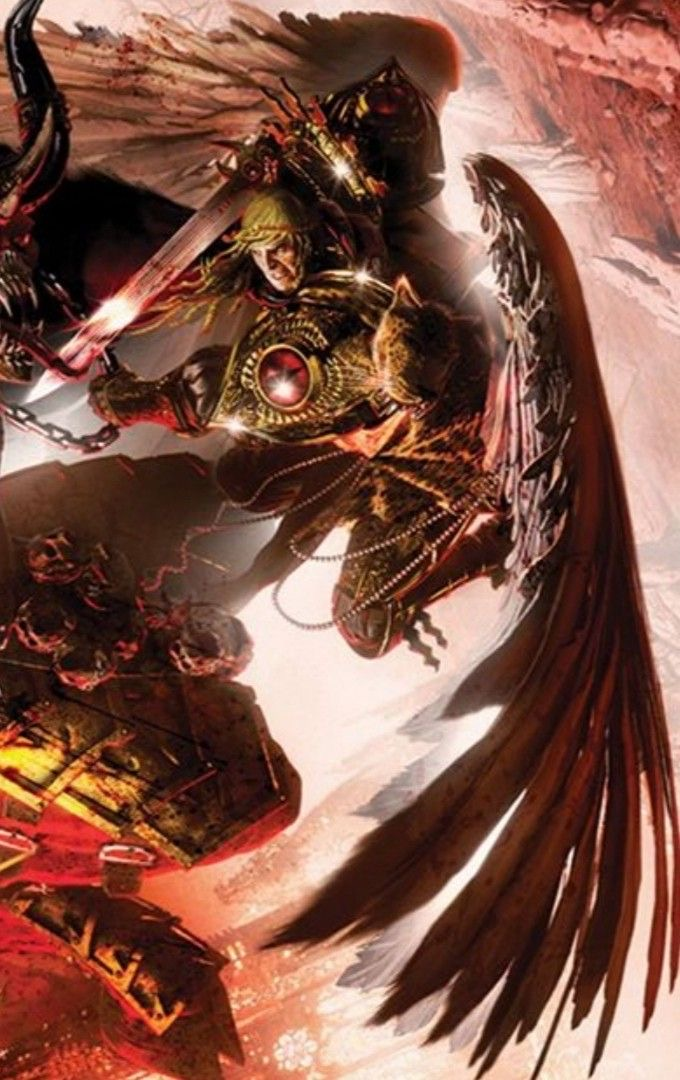describe  The image depicts a dynamic and intense battle scene featuring a figure clad in intricate armor. The character appears to be in mid-action, wielding a glowing sword with a reddish hue. The armor is detailed with golden elements and a prominent red gem on the chest. One of the most striking features of the character is the large, dark wings extending from their back, giving them an imposing and angelic yet fearsome appearance.

The background is chaotic, with what looks like a fiery and war-torn environment, enhancing the sense of conflict and urgency. There are also chains and what appear to be demonic or monstrous elements, suggesting a battle against dark forces. The overall color palette is dominated by reds, oranges, and blacks, emphasizing the fiery and intense nature of the scene. 